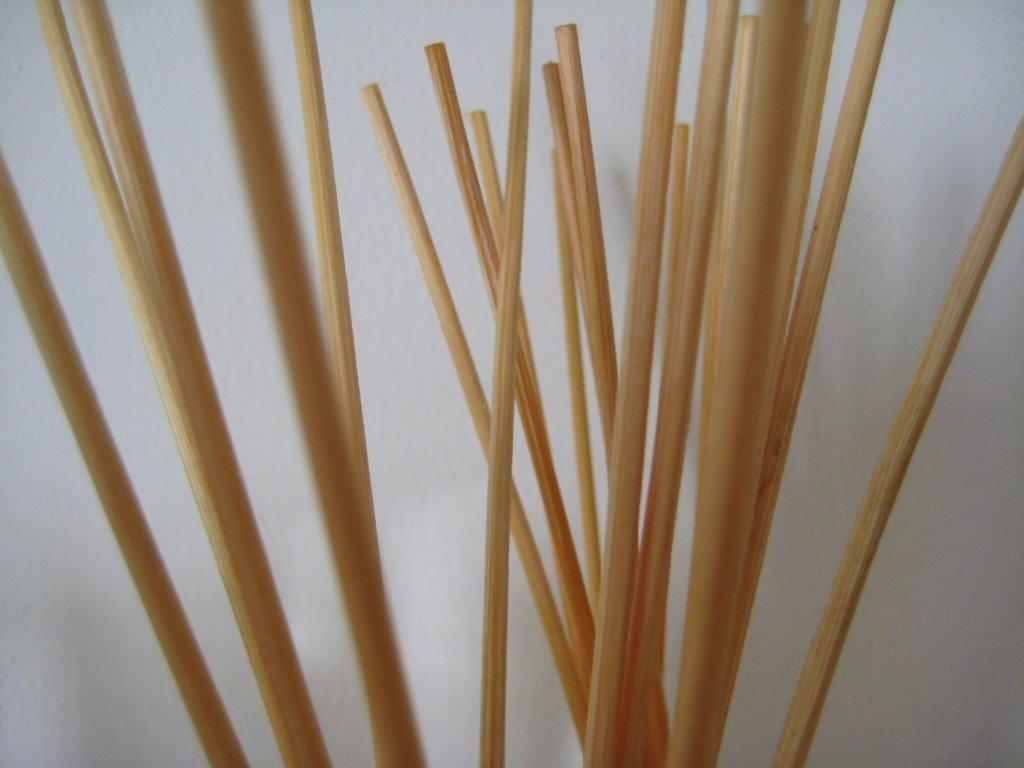In one or two sentences, can you explain what this image depicts? As we can see in the image, there is a white color wall and sticks. 